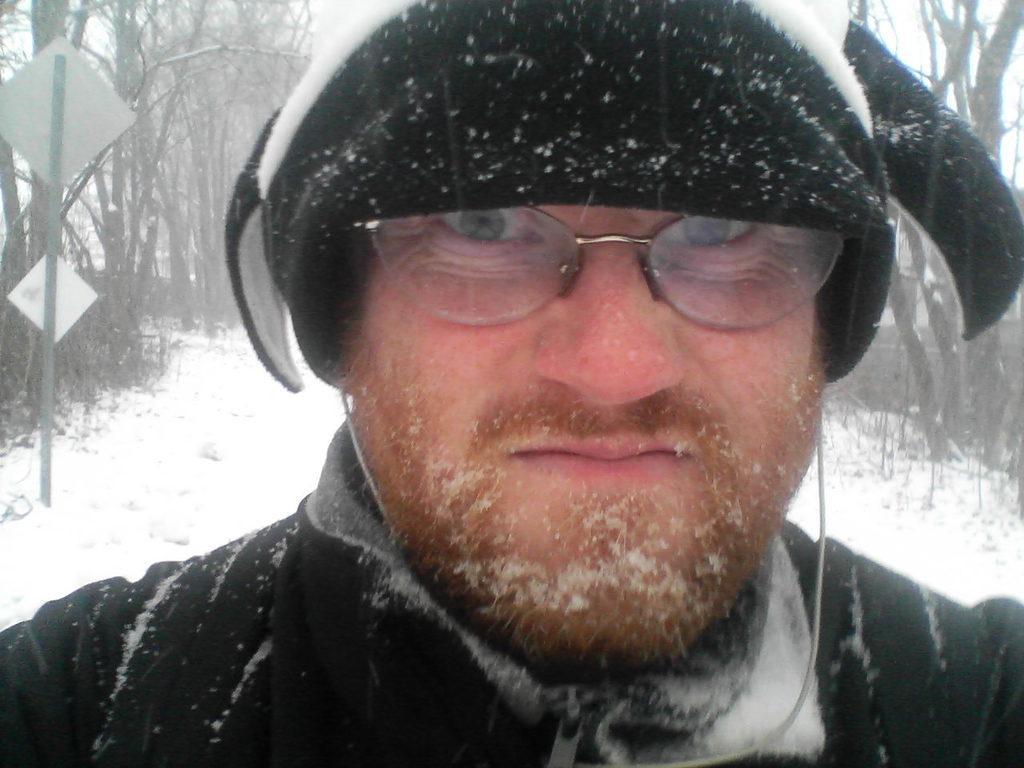Please provide a concise description of this image. In this image I can see a man and I can see he is wearing black colour jacket, specs and a cap. In the background I can see snow, number of trees, a pole and few white colour boards. 